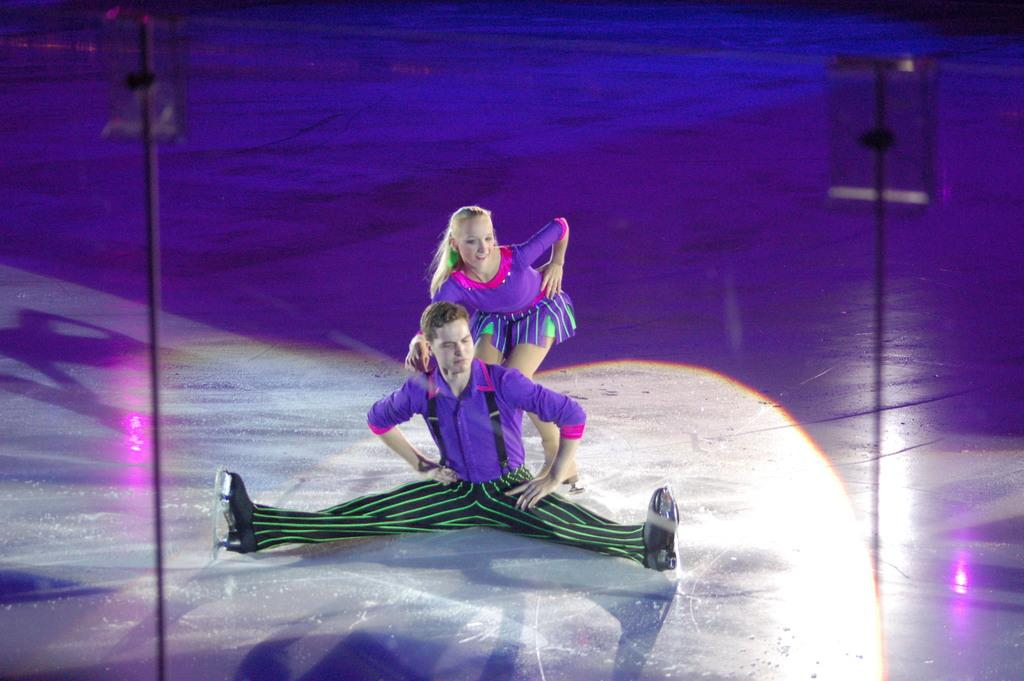Who can be seen in the image? There is a man and a woman in the image. What are the man and the woman wearing? Both the man and the woman are wearing costumes. Where are they performing? They are performing on a dais. What type of metal is used to make the eggnog in the image? There is no eggnog present in the image, and therefore no metal is used to make it. 